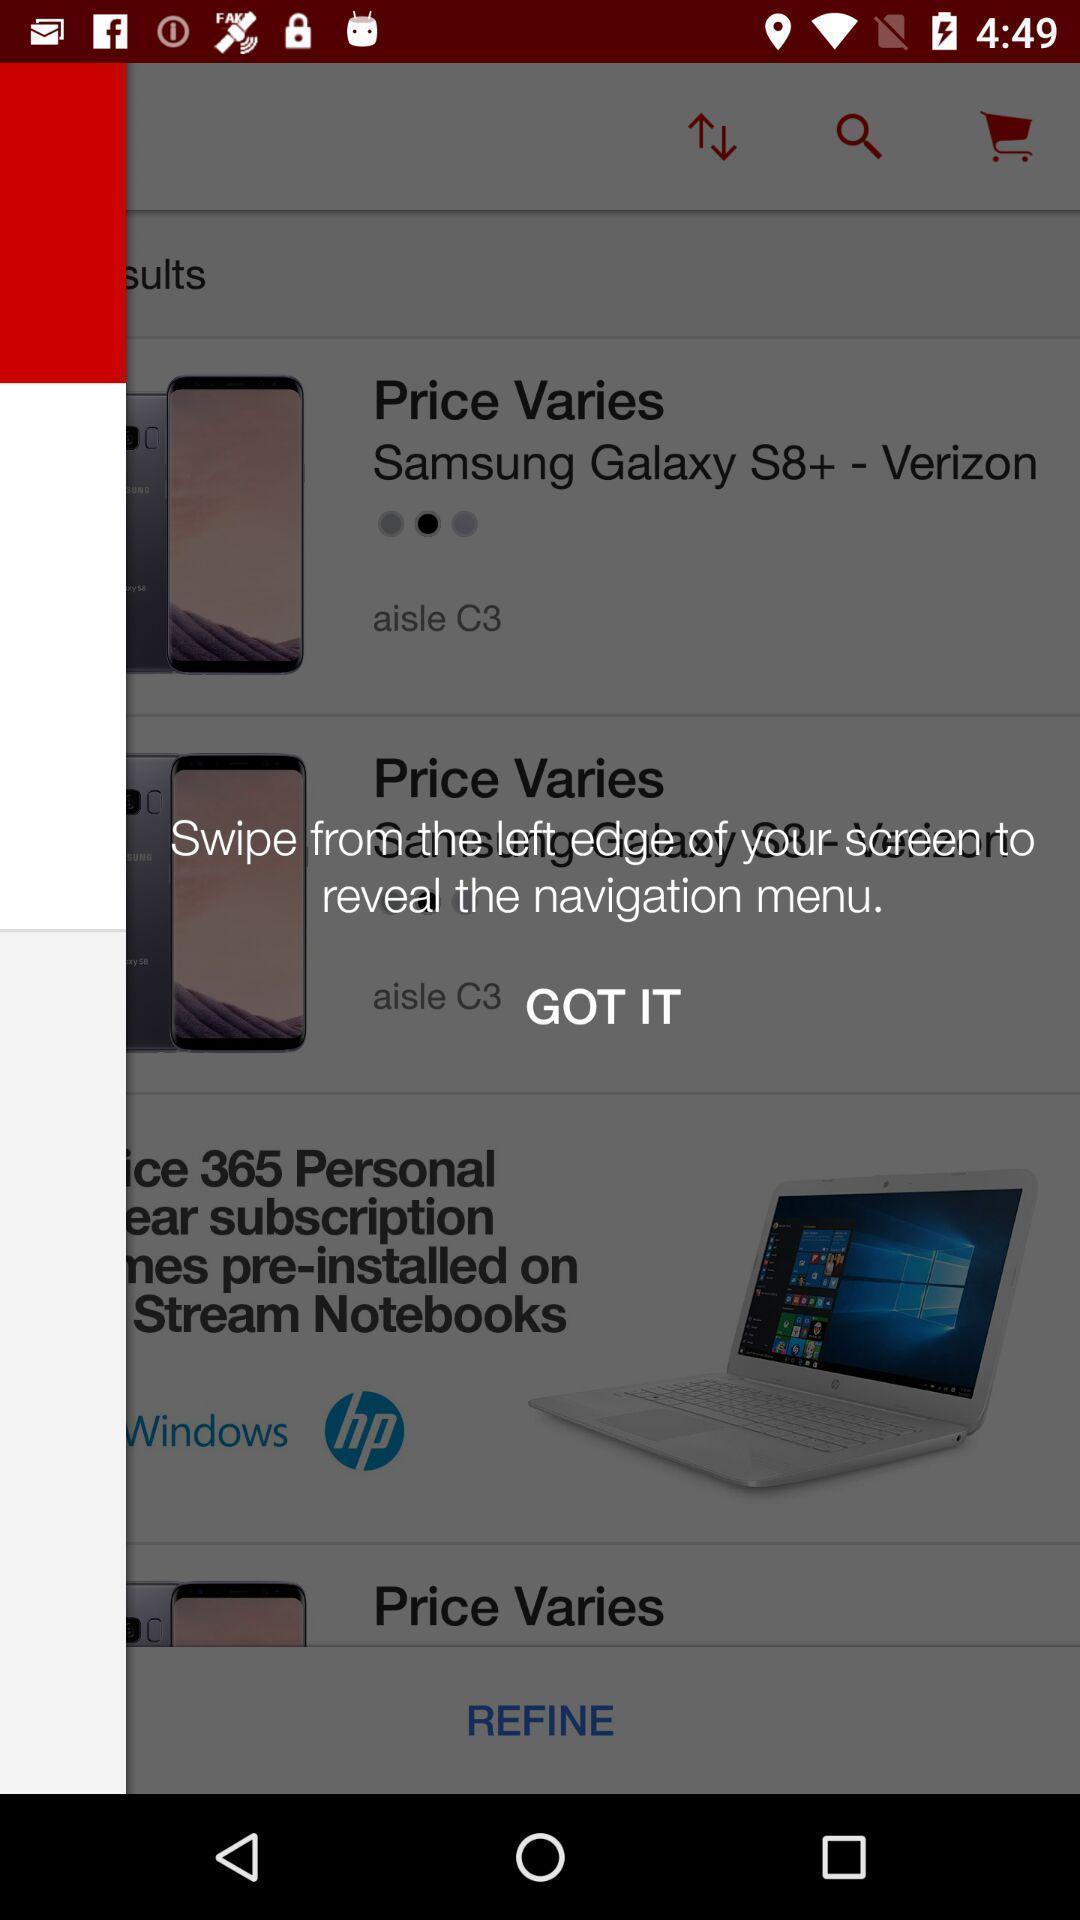Tell me what you see in this picture. Screen displaying page with got it option. 